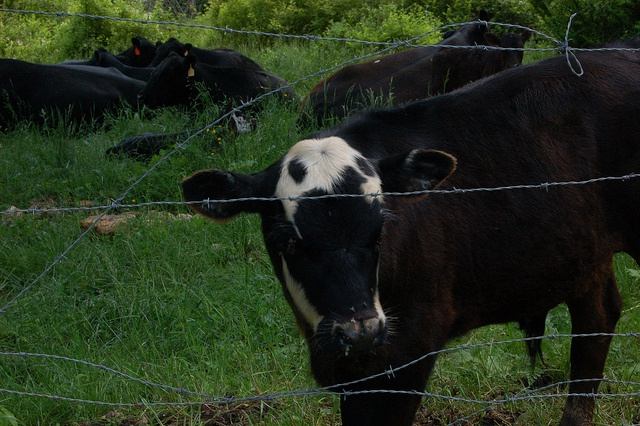Describe the objects in this image and their specific colors. I can see cow in darkgreen, black, gray, and darkgray tones, cow in darkgreen, black, and purple tones, cow in darkgreen, black, and gray tones, cow in darkgreen, black, and gray tones, and cow in darkgreen, black, gray, and purple tones in this image. 